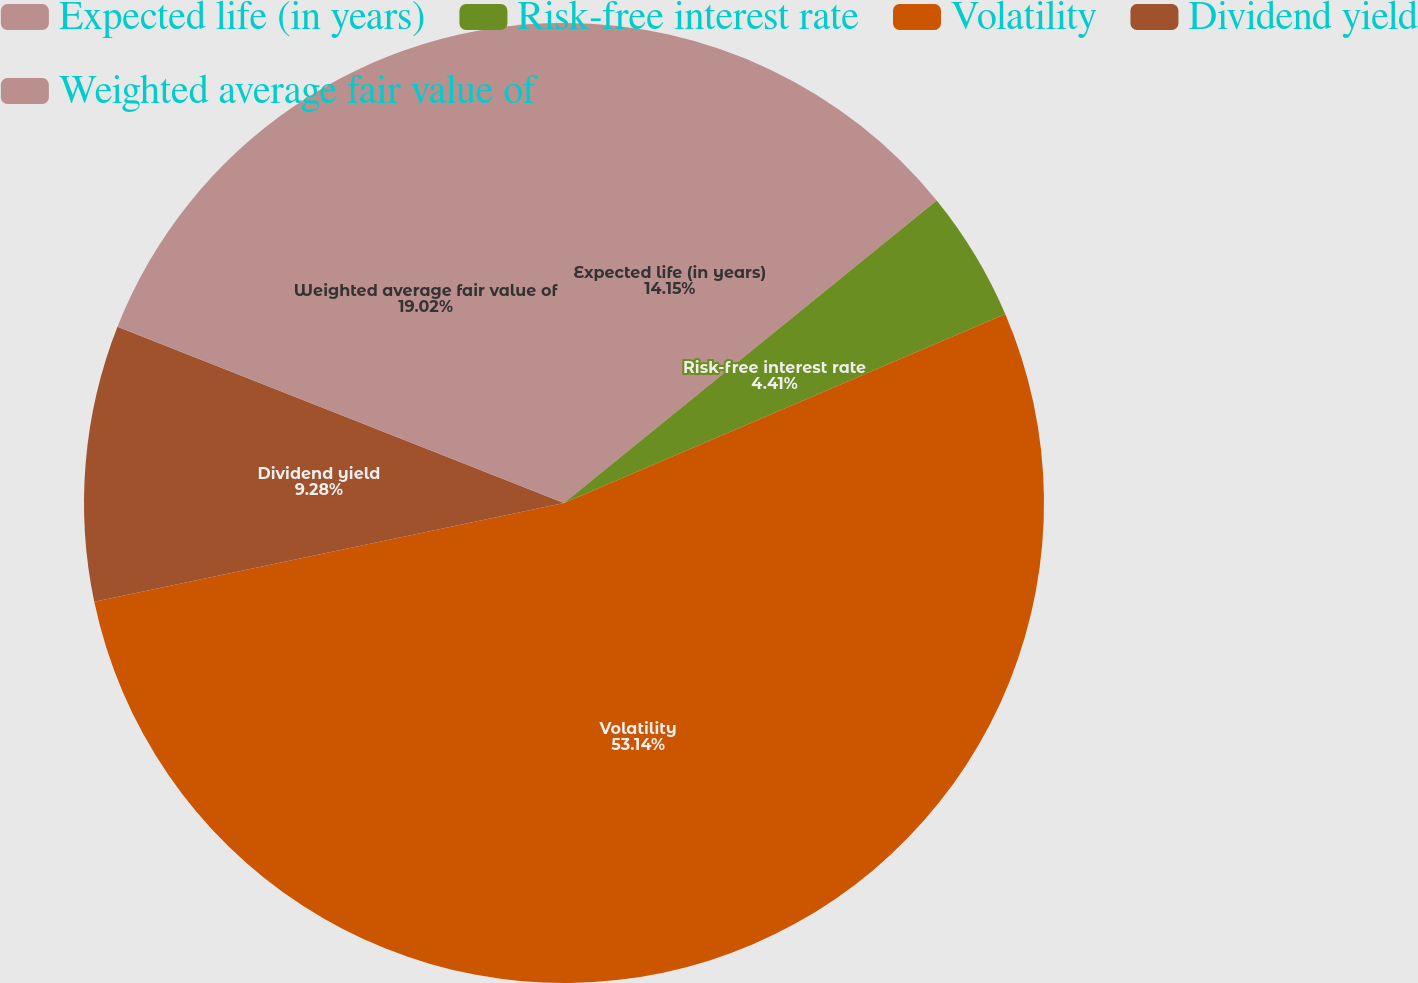Convert chart. <chart><loc_0><loc_0><loc_500><loc_500><pie_chart><fcel>Expected life (in years)<fcel>Risk-free interest rate<fcel>Volatility<fcel>Dividend yield<fcel>Weighted average fair value of<nl><fcel>14.15%<fcel>4.41%<fcel>53.14%<fcel>9.28%<fcel>19.02%<nl></chart> 